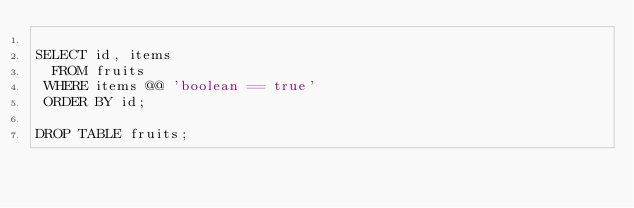<code> <loc_0><loc_0><loc_500><loc_500><_SQL_>
SELECT id, items
  FROM fruits
 WHERE items @@ 'boolean == true'
 ORDER BY id;

DROP TABLE fruits;
</code> 